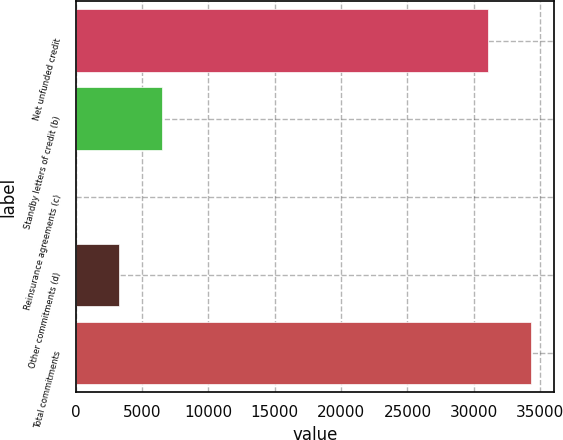<chart> <loc_0><loc_0><loc_500><loc_500><bar_chart><fcel>Net unfunded credit<fcel>Standby letters of credit (b)<fcel>Reinsurance agreements (c)<fcel>Other commitments (d)<fcel>Total commitments<nl><fcel>31060<fcel>6540<fcel>33<fcel>3286.5<fcel>34313.5<nl></chart> 